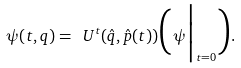<formula> <loc_0><loc_0><loc_500><loc_500>\psi ( t , q ) = \ U ^ { t } ( \hat { q } , \hat { p } ( t ) ) \Big ( \psi \Big | _ { t = 0 } \Big ) .</formula> 